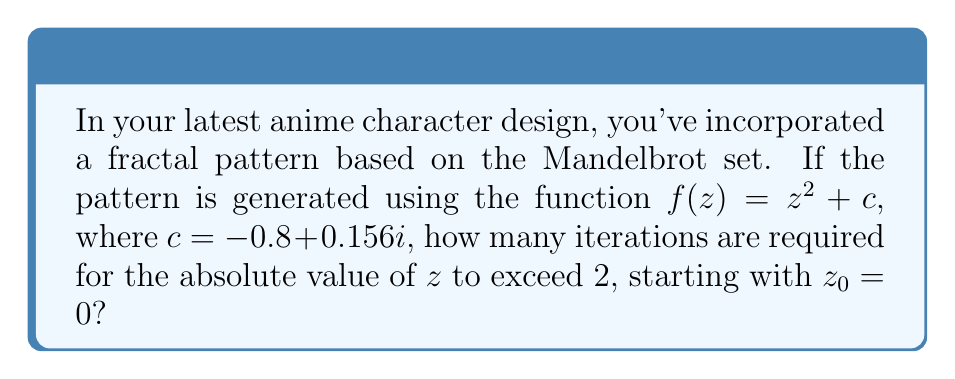Show me your answer to this math problem. To solve this problem, we need to iterate the function $f(z) = z^2 + c$ until $|z| > 2$. Let's go through the iterations step by step:

1) Start with $z_0 = 0$:
   $z_1 = f(z_0) = 0^2 + (-0.8 + 0.156i) = -0.8 + 0.156i$
   $|z_1| = \sqrt{(-0.8)^2 + 0.156^2} \approx 0.814 < 2$

2) Second iteration:
   $z_2 = f(z_1) = (-0.8 + 0.156i)^2 + (-0.8 + 0.156i)$
   $= (0.64 - 0.2496i - 0.024336) + (-0.8 + 0.156i)$
   $= -0.184336 - 0.0936i$
   $|z_2| = \sqrt{(-0.184336)^2 + (-0.0936)^2} \approx 0.207 < 2$

3) Third iteration:
   $z_3 = f(z_2) = (-0.184336 - 0.0936i)^2 + (-0.8 + 0.156i)$
   $= (0.033980 + 0.034519i - 0.008761) + (-0.8 + 0.156i)$
   $= -0.774781 + 0.190519i$
   $|z_3| = \sqrt{(-0.774781)^2 + 0.190519^2} \approx 0.798 < 2$

4) Fourth iteration:
   $z_4 = f(z_3) = (-0.774781 + 0.190519i)^2 + (-0.8 + 0.156i)$
   $= (0.600286 - 0.295375i + 0.036297) + (-0.8 + 0.156i)$
   $= -0.163417 - 0.139375i$
   $|z_4| = \sqrt{(-0.163417)^2 + (-0.139375)^2} \approx 0.215 < 2$

5) Fifth iteration:
   $z_5 = f(z_4) = (-0.163417 - 0.139375i)^2 + (-0.8 + 0.156i)$
   $= (0.026705 + 0.045561i - 0.019425) + (-0.8 + 0.156i)$
   $= -0.79272 + 0.201561i$
   $|z_5| = \sqrt{(-0.79272)^2 + 0.201561^2} \approx 0.818 < 2$

6) Sixth iteration:
   $z_6 = f(z_5) = (-0.79272 + 0.201561i)^2 + (-0.8 + 0.156i)$
   $= (0.628406 - 0.319638i + 0.040627) + (-0.8 + 0.156i)$
   $= -0.130967 - 0.163638i$
   $|z_6| = \sqrt{(-0.130967)^2 + (-0.163638)^2} \approx 0.209 < 2$

7) Seventh iteration:
   $z_7 = f(z_6) = (-0.130967 - 0.163638i)^2 + (-0.8 + 0.156i)$
   $= (0.017152 + 0.042867i - 0.026777) + (-0.8 + 0.156i)$
   $= -0.809625 + 0.198867i$
   $|z_7| = \sqrt{(-0.809625)^2 + 0.198867^2} \approx 0.834 < 2$

8) Eighth iteration:
   $z_8 = f(z_7) = (-0.809625 + 0.198867i)^2 + (-0.8 + 0.156i)$
   $= (0.655492 - 0.322051i + 0.039548) + (-0.8 + 0.156i)$
   $= -0.10496 - 0.166051i$
   $|z_8| = \sqrt{(-0.10496)^2 + (-0.166051)^2} \approx 0.196 < 2$

9) Ninth iteration:
   $z_9 = f(z_8) = (-0.10496 - 0.166051i)^2 + (-0.8 + 0.156i)$
   $= (0.011016 + 0.034857i - 0.027573) + (-0.8 + 0.156i)$
   $= -0.816557 + 0.190857i$
   $|z_9| = \sqrt{(-0.816557)^2 + 0.190857^2} \approx 0.838 < 2$

10) Tenth iteration:
    $z_{10} = f(z_9) = (-0.816557 + 0.190857i)^2 + (-0.8 + 0.156i)$
    $= (0.666766 - 0.311744i + 0.036426) + (-0.8 + 0.156i)$
    $= -0.096808 - 0.155744i$
    $|z_{10}| = \sqrt{(-0.096808)^2 + (-0.155744)^2} \approx 0.183 < 2$

The absolute value of $z$ remains less than 2 even after 10 iterations. In fact, for this particular value of $c$, the orbit of 0 under $f(z)$ remains bounded, as it is within the Mandelbrot set. Therefore, $|z|$ will never exceed 2 no matter how many iterations we perform.
Answer: $\infty$ (The orbit never escapes) 